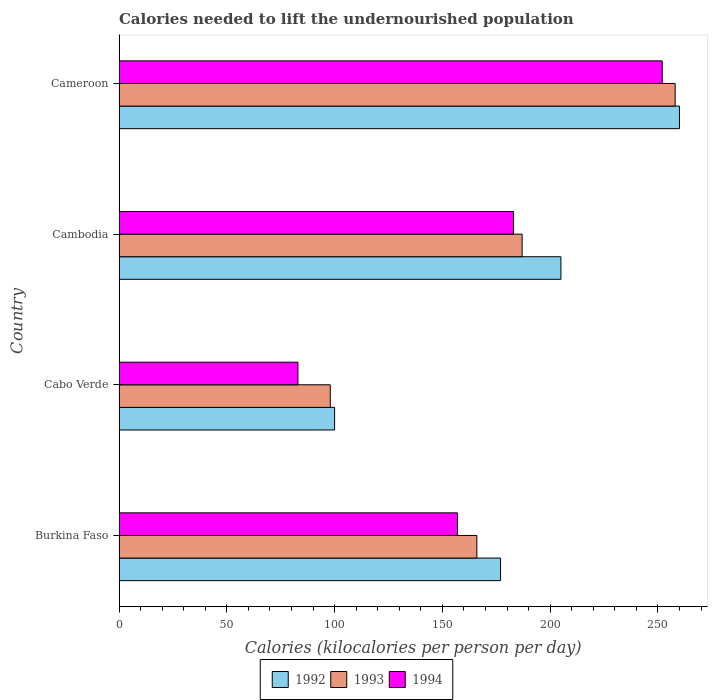Are the number of bars per tick equal to the number of legend labels?
Ensure brevity in your answer.  Yes. Are the number of bars on each tick of the Y-axis equal?
Your answer should be compact. Yes. How many bars are there on the 1st tick from the top?
Provide a succinct answer. 3. How many bars are there on the 4th tick from the bottom?
Your answer should be compact. 3. What is the label of the 4th group of bars from the top?
Your response must be concise. Burkina Faso. What is the total calories needed to lift the undernourished population in 1992 in Cambodia?
Your answer should be compact. 205. Across all countries, what is the maximum total calories needed to lift the undernourished population in 1993?
Keep it short and to the point. 258. Across all countries, what is the minimum total calories needed to lift the undernourished population in 1992?
Ensure brevity in your answer.  100. In which country was the total calories needed to lift the undernourished population in 1993 maximum?
Offer a very short reply. Cameroon. In which country was the total calories needed to lift the undernourished population in 1993 minimum?
Ensure brevity in your answer.  Cabo Verde. What is the total total calories needed to lift the undernourished population in 1992 in the graph?
Ensure brevity in your answer.  742. What is the difference between the total calories needed to lift the undernourished population in 1992 in Cabo Verde and that in Cambodia?
Provide a short and direct response. -105. What is the difference between the total calories needed to lift the undernourished population in 1992 in Cameroon and the total calories needed to lift the undernourished population in 1993 in Cabo Verde?
Provide a succinct answer. 162. What is the average total calories needed to lift the undernourished population in 1994 per country?
Offer a terse response. 168.75. What is the ratio of the total calories needed to lift the undernourished population in 1992 in Cambodia to that in Cameroon?
Ensure brevity in your answer.  0.79. Is the total calories needed to lift the undernourished population in 1992 in Cambodia less than that in Cameroon?
Your response must be concise. Yes. Is the difference between the total calories needed to lift the undernourished population in 1993 in Burkina Faso and Cambodia greater than the difference between the total calories needed to lift the undernourished population in 1994 in Burkina Faso and Cambodia?
Ensure brevity in your answer.  Yes. What is the difference between the highest and the second highest total calories needed to lift the undernourished population in 1994?
Offer a very short reply. 69. What is the difference between the highest and the lowest total calories needed to lift the undernourished population in 1993?
Keep it short and to the point. 160. Is the sum of the total calories needed to lift the undernourished population in 1993 in Cabo Verde and Cameroon greater than the maximum total calories needed to lift the undernourished population in 1994 across all countries?
Keep it short and to the point. Yes. What does the 3rd bar from the top in Burkina Faso represents?
Ensure brevity in your answer.  1992. How many bars are there?
Your answer should be compact. 12. How many countries are there in the graph?
Give a very brief answer. 4. What is the difference between two consecutive major ticks on the X-axis?
Make the answer very short. 50. Does the graph contain any zero values?
Provide a short and direct response. No. Does the graph contain grids?
Offer a terse response. No. How many legend labels are there?
Ensure brevity in your answer.  3. What is the title of the graph?
Make the answer very short. Calories needed to lift the undernourished population. Does "1998" appear as one of the legend labels in the graph?
Your answer should be compact. No. What is the label or title of the X-axis?
Provide a succinct answer. Calories (kilocalories per person per day). What is the label or title of the Y-axis?
Offer a very short reply. Country. What is the Calories (kilocalories per person per day) of 1992 in Burkina Faso?
Make the answer very short. 177. What is the Calories (kilocalories per person per day) of 1993 in Burkina Faso?
Offer a terse response. 166. What is the Calories (kilocalories per person per day) in 1994 in Burkina Faso?
Your response must be concise. 157. What is the Calories (kilocalories per person per day) of 1992 in Cabo Verde?
Give a very brief answer. 100. What is the Calories (kilocalories per person per day) in 1992 in Cambodia?
Make the answer very short. 205. What is the Calories (kilocalories per person per day) in 1993 in Cambodia?
Make the answer very short. 187. What is the Calories (kilocalories per person per day) in 1994 in Cambodia?
Ensure brevity in your answer.  183. What is the Calories (kilocalories per person per day) of 1992 in Cameroon?
Keep it short and to the point. 260. What is the Calories (kilocalories per person per day) of 1993 in Cameroon?
Keep it short and to the point. 258. What is the Calories (kilocalories per person per day) in 1994 in Cameroon?
Your answer should be very brief. 252. Across all countries, what is the maximum Calories (kilocalories per person per day) of 1992?
Keep it short and to the point. 260. Across all countries, what is the maximum Calories (kilocalories per person per day) of 1993?
Offer a terse response. 258. Across all countries, what is the maximum Calories (kilocalories per person per day) in 1994?
Provide a short and direct response. 252. Across all countries, what is the minimum Calories (kilocalories per person per day) of 1994?
Give a very brief answer. 83. What is the total Calories (kilocalories per person per day) of 1992 in the graph?
Give a very brief answer. 742. What is the total Calories (kilocalories per person per day) in 1993 in the graph?
Your answer should be compact. 709. What is the total Calories (kilocalories per person per day) in 1994 in the graph?
Your response must be concise. 675. What is the difference between the Calories (kilocalories per person per day) of 1992 in Burkina Faso and that in Cambodia?
Keep it short and to the point. -28. What is the difference between the Calories (kilocalories per person per day) of 1994 in Burkina Faso and that in Cambodia?
Provide a short and direct response. -26. What is the difference between the Calories (kilocalories per person per day) in 1992 in Burkina Faso and that in Cameroon?
Ensure brevity in your answer.  -83. What is the difference between the Calories (kilocalories per person per day) in 1993 in Burkina Faso and that in Cameroon?
Offer a terse response. -92. What is the difference between the Calories (kilocalories per person per day) in 1994 in Burkina Faso and that in Cameroon?
Provide a succinct answer. -95. What is the difference between the Calories (kilocalories per person per day) of 1992 in Cabo Verde and that in Cambodia?
Make the answer very short. -105. What is the difference between the Calories (kilocalories per person per day) in 1993 in Cabo Verde and that in Cambodia?
Make the answer very short. -89. What is the difference between the Calories (kilocalories per person per day) of 1994 in Cabo Verde and that in Cambodia?
Provide a succinct answer. -100. What is the difference between the Calories (kilocalories per person per day) in 1992 in Cabo Verde and that in Cameroon?
Provide a short and direct response. -160. What is the difference between the Calories (kilocalories per person per day) in 1993 in Cabo Verde and that in Cameroon?
Your response must be concise. -160. What is the difference between the Calories (kilocalories per person per day) of 1994 in Cabo Verde and that in Cameroon?
Give a very brief answer. -169. What is the difference between the Calories (kilocalories per person per day) in 1992 in Cambodia and that in Cameroon?
Ensure brevity in your answer.  -55. What is the difference between the Calories (kilocalories per person per day) in 1993 in Cambodia and that in Cameroon?
Offer a terse response. -71. What is the difference between the Calories (kilocalories per person per day) in 1994 in Cambodia and that in Cameroon?
Give a very brief answer. -69. What is the difference between the Calories (kilocalories per person per day) in 1992 in Burkina Faso and the Calories (kilocalories per person per day) in 1993 in Cabo Verde?
Keep it short and to the point. 79. What is the difference between the Calories (kilocalories per person per day) of 1992 in Burkina Faso and the Calories (kilocalories per person per day) of 1994 in Cabo Verde?
Provide a succinct answer. 94. What is the difference between the Calories (kilocalories per person per day) in 1993 in Burkina Faso and the Calories (kilocalories per person per day) in 1994 in Cabo Verde?
Ensure brevity in your answer.  83. What is the difference between the Calories (kilocalories per person per day) in 1992 in Burkina Faso and the Calories (kilocalories per person per day) in 1994 in Cambodia?
Offer a very short reply. -6. What is the difference between the Calories (kilocalories per person per day) of 1992 in Burkina Faso and the Calories (kilocalories per person per day) of 1993 in Cameroon?
Make the answer very short. -81. What is the difference between the Calories (kilocalories per person per day) of 1992 in Burkina Faso and the Calories (kilocalories per person per day) of 1994 in Cameroon?
Offer a very short reply. -75. What is the difference between the Calories (kilocalories per person per day) of 1993 in Burkina Faso and the Calories (kilocalories per person per day) of 1994 in Cameroon?
Your response must be concise. -86. What is the difference between the Calories (kilocalories per person per day) of 1992 in Cabo Verde and the Calories (kilocalories per person per day) of 1993 in Cambodia?
Offer a terse response. -87. What is the difference between the Calories (kilocalories per person per day) of 1992 in Cabo Verde and the Calories (kilocalories per person per day) of 1994 in Cambodia?
Offer a very short reply. -83. What is the difference between the Calories (kilocalories per person per day) in 1993 in Cabo Verde and the Calories (kilocalories per person per day) in 1994 in Cambodia?
Offer a terse response. -85. What is the difference between the Calories (kilocalories per person per day) of 1992 in Cabo Verde and the Calories (kilocalories per person per day) of 1993 in Cameroon?
Your answer should be very brief. -158. What is the difference between the Calories (kilocalories per person per day) in 1992 in Cabo Verde and the Calories (kilocalories per person per day) in 1994 in Cameroon?
Your answer should be compact. -152. What is the difference between the Calories (kilocalories per person per day) in 1993 in Cabo Verde and the Calories (kilocalories per person per day) in 1994 in Cameroon?
Your response must be concise. -154. What is the difference between the Calories (kilocalories per person per day) of 1992 in Cambodia and the Calories (kilocalories per person per day) of 1993 in Cameroon?
Your answer should be compact. -53. What is the difference between the Calories (kilocalories per person per day) of 1992 in Cambodia and the Calories (kilocalories per person per day) of 1994 in Cameroon?
Give a very brief answer. -47. What is the difference between the Calories (kilocalories per person per day) in 1993 in Cambodia and the Calories (kilocalories per person per day) in 1994 in Cameroon?
Ensure brevity in your answer.  -65. What is the average Calories (kilocalories per person per day) of 1992 per country?
Your answer should be compact. 185.5. What is the average Calories (kilocalories per person per day) in 1993 per country?
Provide a succinct answer. 177.25. What is the average Calories (kilocalories per person per day) of 1994 per country?
Provide a succinct answer. 168.75. What is the difference between the Calories (kilocalories per person per day) of 1992 and Calories (kilocalories per person per day) of 1993 in Burkina Faso?
Provide a succinct answer. 11. What is the difference between the Calories (kilocalories per person per day) of 1993 and Calories (kilocalories per person per day) of 1994 in Burkina Faso?
Your answer should be very brief. 9. What is the difference between the Calories (kilocalories per person per day) in 1992 and Calories (kilocalories per person per day) in 1993 in Cabo Verde?
Provide a short and direct response. 2. What is the difference between the Calories (kilocalories per person per day) of 1992 and Calories (kilocalories per person per day) of 1994 in Cambodia?
Offer a terse response. 22. What is the difference between the Calories (kilocalories per person per day) in 1993 and Calories (kilocalories per person per day) in 1994 in Cambodia?
Your answer should be very brief. 4. What is the difference between the Calories (kilocalories per person per day) in 1992 and Calories (kilocalories per person per day) in 1994 in Cameroon?
Provide a succinct answer. 8. What is the ratio of the Calories (kilocalories per person per day) of 1992 in Burkina Faso to that in Cabo Verde?
Your answer should be very brief. 1.77. What is the ratio of the Calories (kilocalories per person per day) of 1993 in Burkina Faso to that in Cabo Verde?
Your answer should be very brief. 1.69. What is the ratio of the Calories (kilocalories per person per day) of 1994 in Burkina Faso to that in Cabo Verde?
Offer a terse response. 1.89. What is the ratio of the Calories (kilocalories per person per day) of 1992 in Burkina Faso to that in Cambodia?
Ensure brevity in your answer.  0.86. What is the ratio of the Calories (kilocalories per person per day) of 1993 in Burkina Faso to that in Cambodia?
Keep it short and to the point. 0.89. What is the ratio of the Calories (kilocalories per person per day) of 1994 in Burkina Faso to that in Cambodia?
Make the answer very short. 0.86. What is the ratio of the Calories (kilocalories per person per day) in 1992 in Burkina Faso to that in Cameroon?
Give a very brief answer. 0.68. What is the ratio of the Calories (kilocalories per person per day) in 1993 in Burkina Faso to that in Cameroon?
Your answer should be very brief. 0.64. What is the ratio of the Calories (kilocalories per person per day) in 1994 in Burkina Faso to that in Cameroon?
Offer a terse response. 0.62. What is the ratio of the Calories (kilocalories per person per day) of 1992 in Cabo Verde to that in Cambodia?
Offer a terse response. 0.49. What is the ratio of the Calories (kilocalories per person per day) of 1993 in Cabo Verde to that in Cambodia?
Your answer should be compact. 0.52. What is the ratio of the Calories (kilocalories per person per day) in 1994 in Cabo Verde to that in Cambodia?
Keep it short and to the point. 0.45. What is the ratio of the Calories (kilocalories per person per day) of 1992 in Cabo Verde to that in Cameroon?
Your answer should be very brief. 0.38. What is the ratio of the Calories (kilocalories per person per day) of 1993 in Cabo Verde to that in Cameroon?
Your response must be concise. 0.38. What is the ratio of the Calories (kilocalories per person per day) of 1994 in Cabo Verde to that in Cameroon?
Give a very brief answer. 0.33. What is the ratio of the Calories (kilocalories per person per day) in 1992 in Cambodia to that in Cameroon?
Provide a short and direct response. 0.79. What is the ratio of the Calories (kilocalories per person per day) of 1993 in Cambodia to that in Cameroon?
Give a very brief answer. 0.72. What is the ratio of the Calories (kilocalories per person per day) of 1994 in Cambodia to that in Cameroon?
Give a very brief answer. 0.73. What is the difference between the highest and the second highest Calories (kilocalories per person per day) in 1992?
Provide a short and direct response. 55. What is the difference between the highest and the second highest Calories (kilocalories per person per day) of 1993?
Keep it short and to the point. 71. What is the difference between the highest and the second highest Calories (kilocalories per person per day) in 1994?
Give a very brief answer. 69. What is the difference between the highest and the lowest Calories (kilocalories per person per day) of 1992?
Give a very brief answer. 160. What is the difference between the highest and the lowest Calories (kilocalories per person per day) in 1993?
Provide a succinct answer. 160. What is the difference between the highest and the lowest Calories (kilocalories per person per day) in 1994?
Ensure brevity in your answer.  169. 